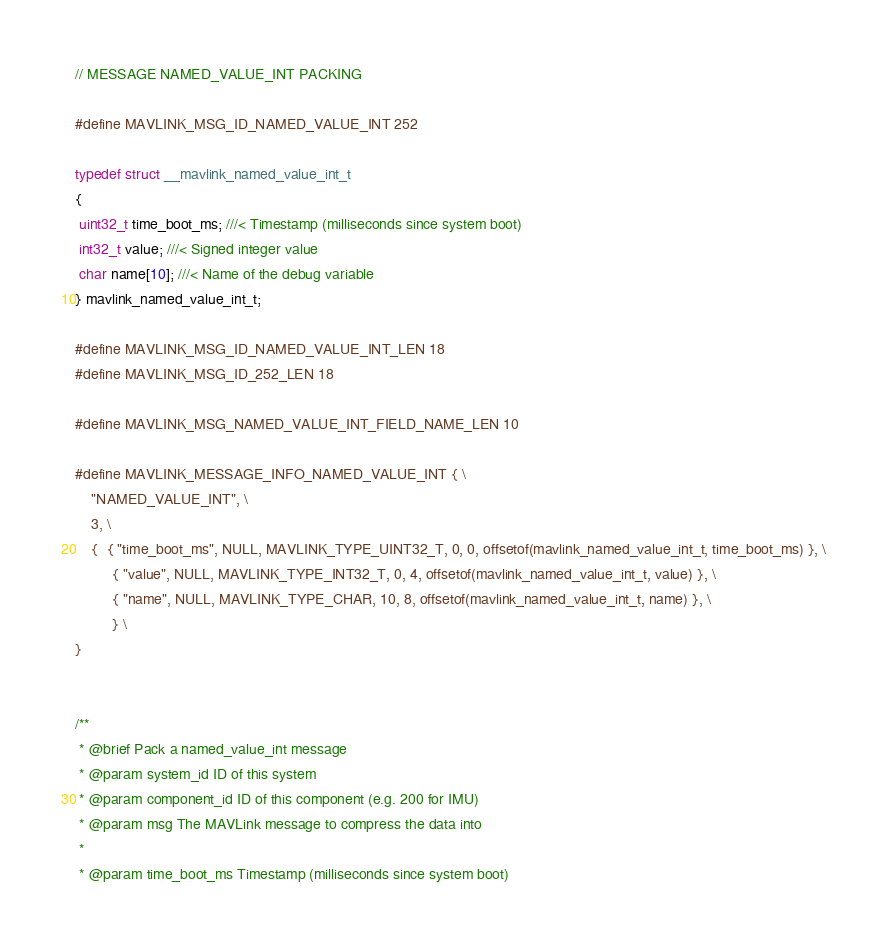Convert code to text. <code><loc_0><loc_0><loc_500><loc_500><_C_>// MESSAGE NAMED_VALUE_INT PACKING

#define MAVLINK_MSG_ID_NAMED_VALUE_INT 252

typedef struct __mavlink_named_value_int_t
{
 uint32_t time_boot_ms; ///< Timestamp (milliseconds since system boot)
 int32_t value; ///< Signed integer value
 char name[10]; ///< Name of the debug variable
} mavlink_named_value_int_t;

#define MAVLINK_MSG_ID_NAMED_VALUE_INT_LEN 18
#define MAVLINK_MSG_ID_252_LEN 18

#define MAVLINK_MSG_NAMED_VALUE_INT_FIELD_NAME_LEN 10

#define MAVLINK_MESSAGE_INFO_NAMED_VALUE_INT { \
	"NAMED_VALUE_INT", \
	3, \
	{  { "time_boot_ms", NULL, MAVLINK_TYPE_UINT32_T, 0, 0, offsetof(mavlink_named_value_int_t, time_boot_ms) }, \
         { "value", NULL, MAVLINK_TYPE_INT32_T, 0, 4, offsetof(mavlink_named_value_int_t, value) }, \
         { "name", NULL, MAVLINK_TYPE_CHAR, 10, 8, offsetof(mavlink_named_value_int_t, name) }, \
         } \
}


/**
 * @brief Pack a named_value_int message
 * @param system_id ID of this system
 * @param component_id ID of this component (e.g. 200 for IMU)
 * @param msg The MAVLink message to compress the data into
 *
 * @param time_boot_ms Timestamp (milliseconds since system boot)</code> 